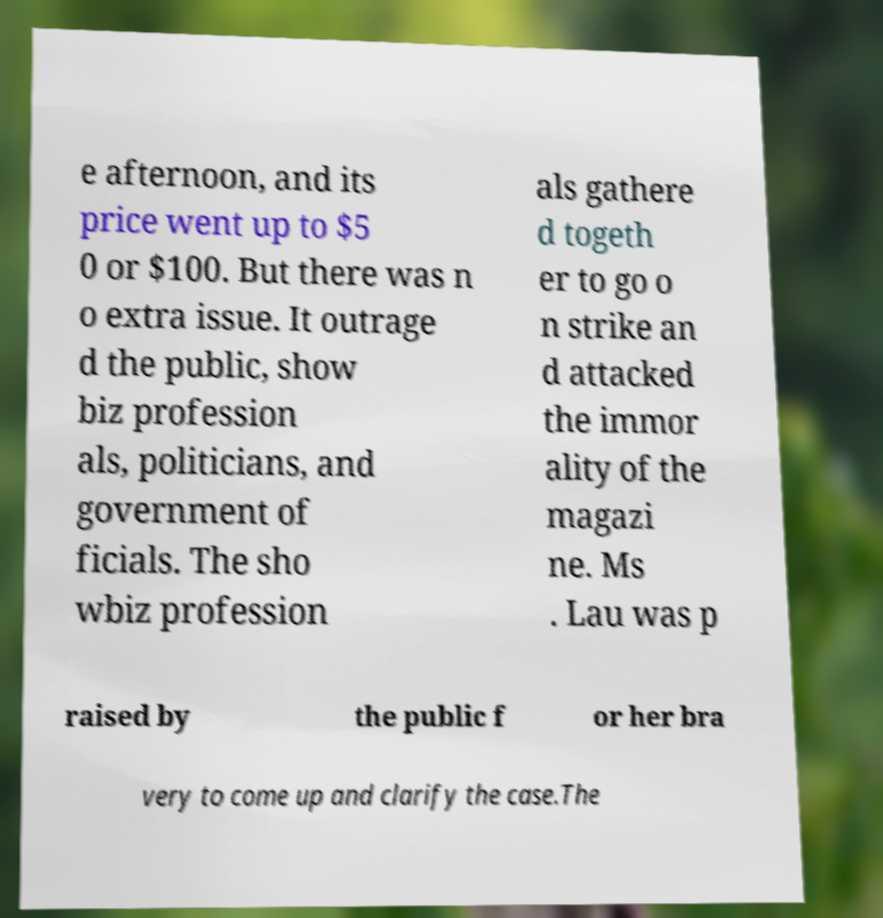Could you assist in decoding the text presented in this image and type it out clearly? e afternoon, and its price went up to $5 0 or $100. But there was n o extra issue. It outrage d the public, show biz profession als, politicians, and government of ficials. The sho wbiz profession als gathere d togeth er to go o n strike an d attacked the immor ality of the magazi ne. Ms . Lau was p raised by the public f or her bra very to come up and clarify the case.The 